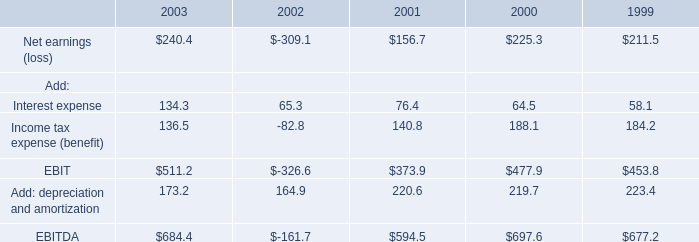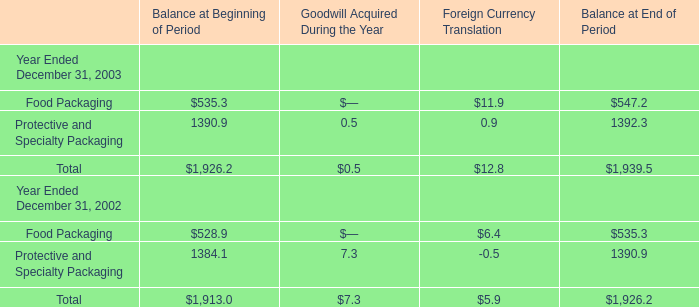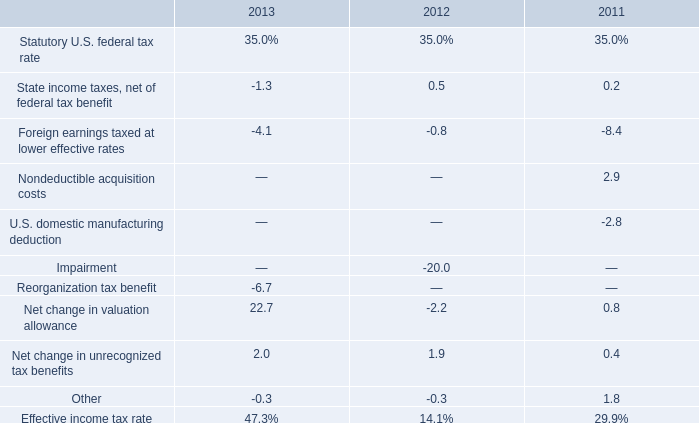What is the sum of the Total for Balance at Beginning of Period in the years where Food Packaging greater than 500 for Balance at Beginning of Period? 
Computations: (1926.2 + 1913.0)
Answer: 3839.2. 